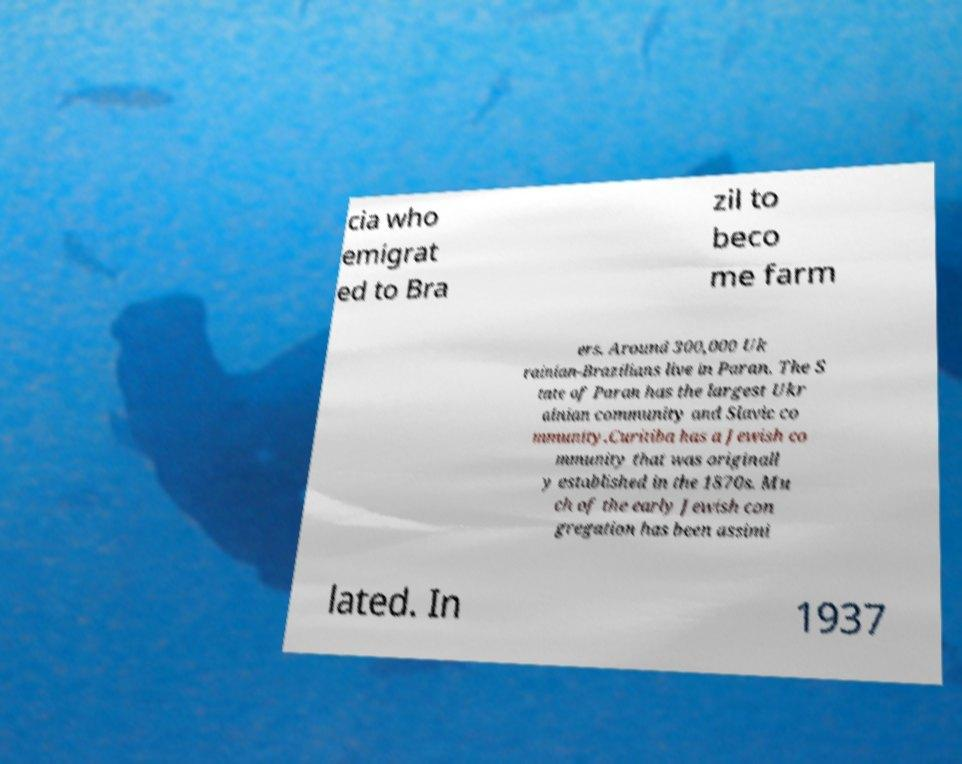Can you read and provide the text displayed in the image?This photo seems to have some interesting text. Can you extract and type it out for me? cia who emigrat ed to Bra zil to beco me farm ers. Around 300,000 Uk rainian-Brazilians live in Paran. The S tate of Paran has the largest Ukr ainian community and Slavic co mmunity.Curitiba has a Jewish co mmunity that was originall y established in the 1870s. Mu ch of the early Jewish con gregation has been assimi lated. In 1937 